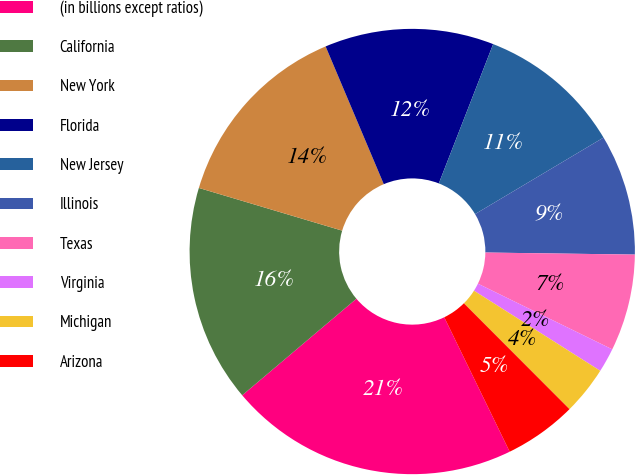Convert chart to OTSL. <chart><loc_0><loc_0><loc_500><loc_500><pie_chart><fcel>(in billions except ratios)<fcel>California<fcel>New York<fcel>Florida<fcel>New Jersey<fcel>Illinois<fcel>Texas<fcel>Virginia<fcel>Michigan<fcel>Arizona<nl><fcel>21.04%<fcel>15.78%<fcel>14.03%<fcel>12.28%<fcel>10.53%<fcel>8.77%<fcel>7.02%<fcel>1.76%<fcel>3.52%<fcel>5.27%<nl></chart> 